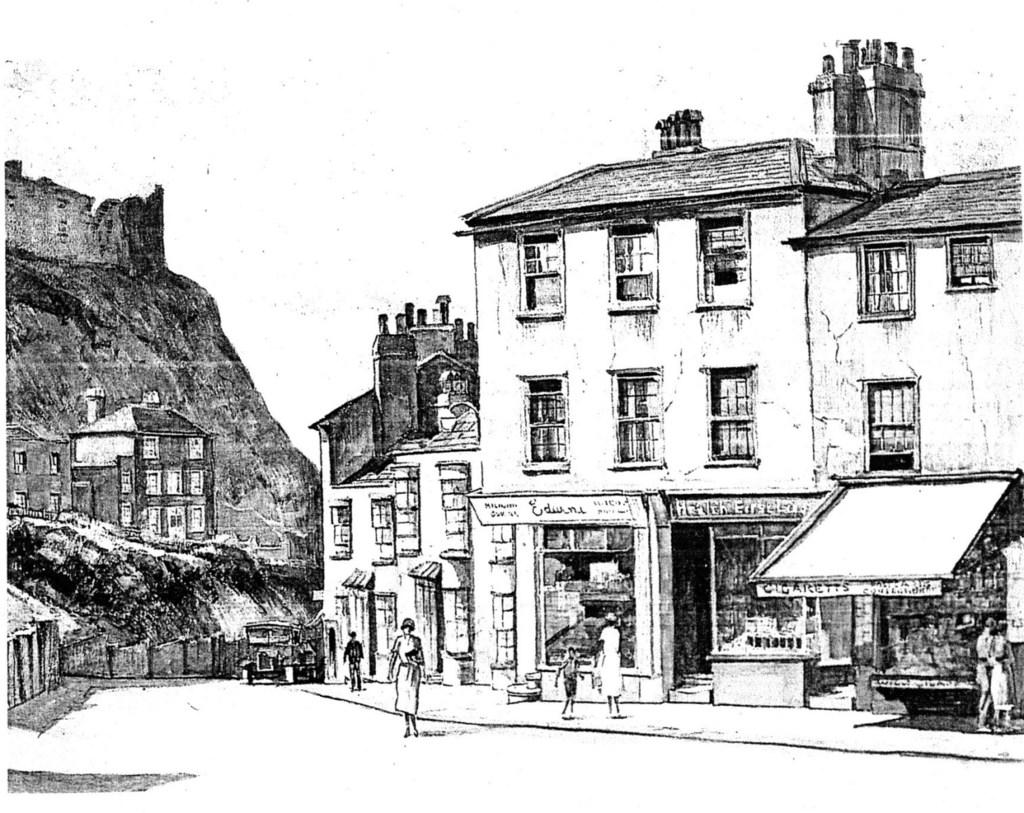What type of structures can be seen in the image? There are houses in the image. Are there any people visible in the image? Yes, there are persons in the image. What mode of transportation is present in the image? There is a vehicle in the image. What type of historical or defensive structure can be seen in the image? There is a fort in the image. What type of shoes are the persons wearing in the image? There is no information about the shoes worn by the persons in the image. Can you tell me the profession of the person standing next to the fort? There is no information about the profession of any person in the image. 